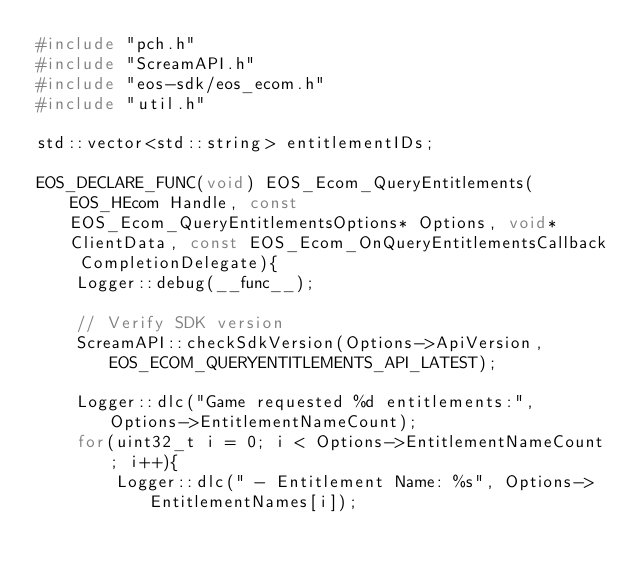Convert code to text. <code><loc_0><loc_0><loc_500><loc_500><_C++_>#include "pch.h"
#include "ScreamAPI.h"
#include "eos-sdk/eos_ecom.h"
#include "util.h"

std::vector<std::string> entitlementIDs;

EOS_DECLARE_FUNC(void) EOS_Ecom_QueryEntitlements(EOS_HEcom Handle, const EOS_Ecom_QueryEntitlementsOptions* Options, void* ClientData, const EOS_Ecom_OnQueryEntitlementsCallback CompletionDelegate){
	Logger::debug(__func__);

	// Verify SDK version
	ScreamAPI::checkSdkVersion(Options->ApiVersion, EOS_ECOM_QUERYENTITLEMENTS_API_LATEST);

	Logger::dlc("Game requested %d entitlements:", Options->EntitlementNameCount);
	for(uint32_t i = 0; i < Options->EntitlementNameCount; i++){
		Logger::dlc(" - Entitlement Name: %s", Options->EntitlementNames[i]);
</code> 